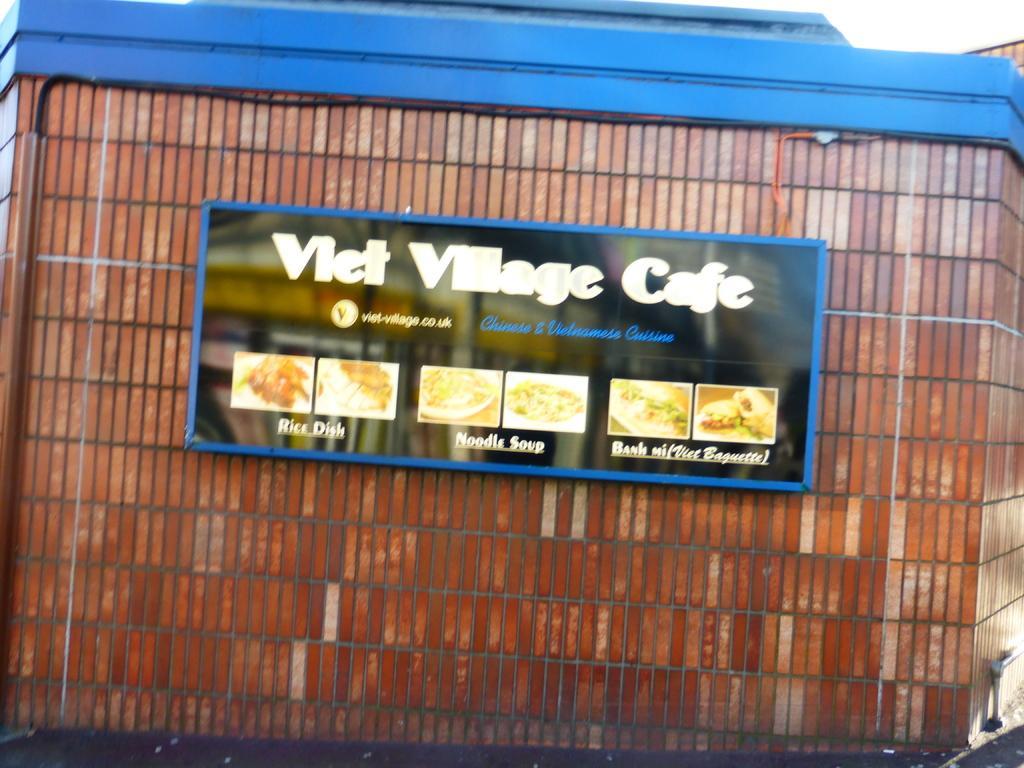Can you describe this image briefly? In this image I can see a building. In the middle of the image there is a board attached to this building. On this board, I can see some text and few images of different food items. At the top of the image I can see the sky. 